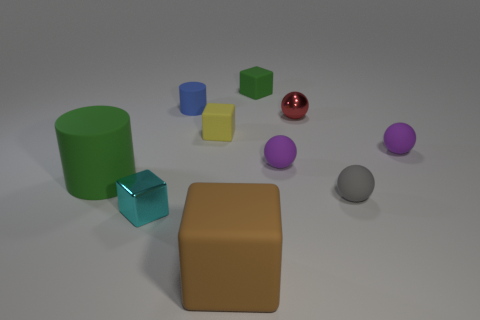The matte object that is the same color as the big cylinder is what shape?
Provide a short and direct response. Cube. Are there any small matte cubes of the same color as the large cylinder?
Make the answer very short. Yes. Is the number of tiny objects behind the cyan thing the same as the number of things that are on the right side of the blue rubber cylinder?
Ensure brevity in your answer.  Yes. Do the purple matte object that is left of the small red shiny ball and the metal thing that is right of the brown rubber object have the same shape?
Your response must be concise. Yes. There is a green object that is the same material as the small green block; what shape is it?
Your response must be concise. Cylinder. Is the number of yellow objects to the right of the tiny metallic block the same as the number of small yellow matte things?
Ensure brevity in your answer.  Yes. Do the block on the right side of the large brown matte object and the green object left of the small cylinder have the same material?
Offer a terse response. Yes. What shape is the green object in front of the green matte object right of the large green rubber cylinder?
Offer a terse response. Cylinder. What is the color of the large cube that is made of the same material as the small gray thing?
Provide a short and direct response. Brown. There is a green rubber object that is the same size as the brown rubber cube; what is its shape?
Provide a succinct answer. Cylinder. 